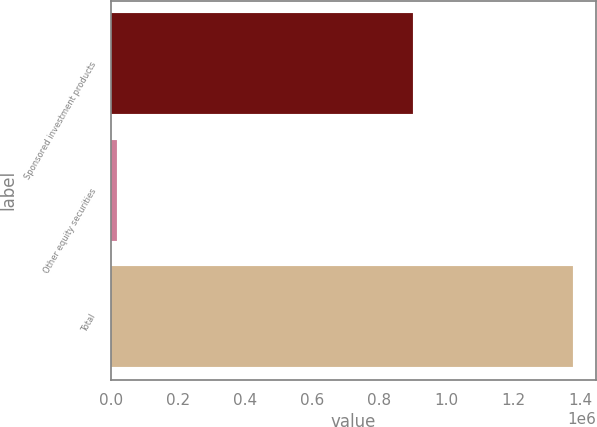<chart> <loc_0><loc_0><loc_500><loc_500><bar_chart><fcel>Sponsored investment products<fcel>Other equity securities<fcel>Total<nl><fcel>901923<fcel>16393<fcel>1.3795e+06<nl></chart> 